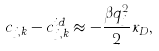<formula> <loc_0><loc_0><loc_500><loc_500>c _ { j , k } - c _ { j , k } ^ { i d } \approx - \frac { \beta q _ { j } ^ { 2 } } { 2 } \kappa _ { D } ,</formula> 